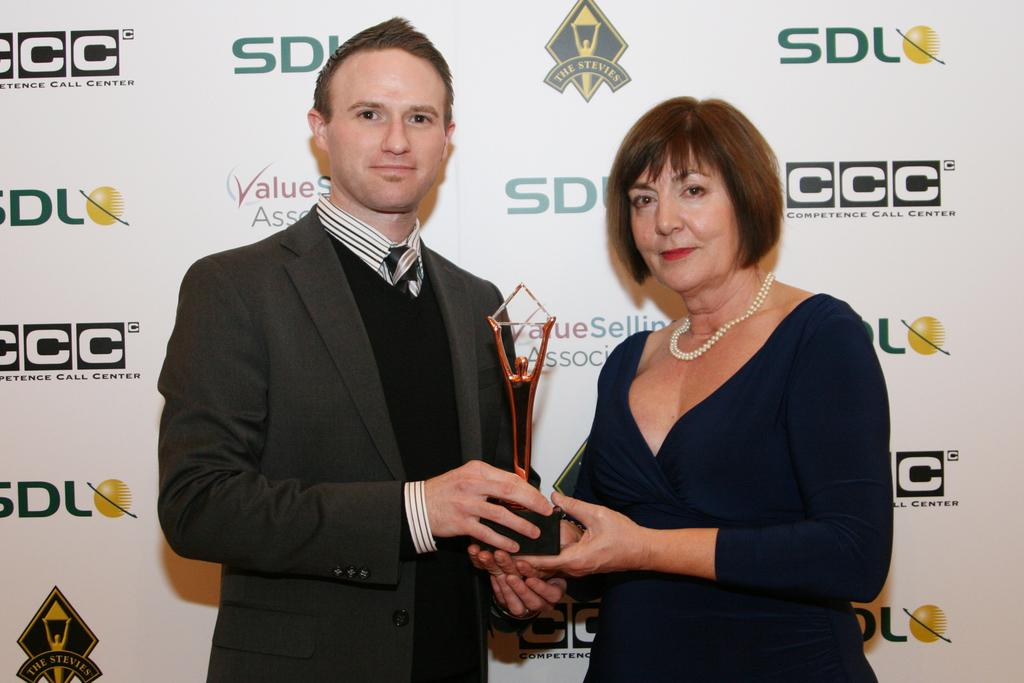Who is present in the image? There is a man and a woman in the image. What are the man and the woman holding? Both the man and the woman are holding a trophy. What can be seen in the background of the image? There is a banner in the background of the image. What type of key is the man using to unlock the watch in the image? There is no key or watch present in the image; the man and woman are holding trophies. 